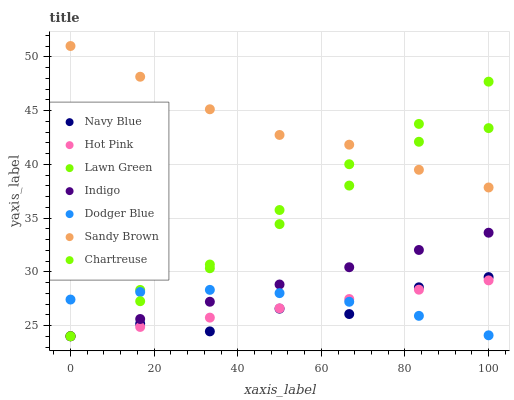Does Navy Blue have the minimum area under the curve?
Answer yes or no. Yes. Does Sandy Brown have the maximum area under the curve?
Answer yes or no. Yes. Does Indigo have the minimum area under the curve?
Answer yes or no. No. Does Indigo have the maximum area under the curve?
Answer yes or no. No. Is Hot Pink the smoothest?
Answer yes or no. Yes. Is Navy Blue the roughest?
Answer yes or no. Yes. Is Indigo the smoothest?
Answer yes or no. No. Is Indigo the roughest?
Answer yes or no. No. Does Lawn Green have the lowest value?
Answer yes or no. Yes. Does Dodger Blue have the lowest value?
Answer yes or no. No. Does Sandy Brown have the highest value?
Answer yes or no. Yes. Does Indigo have the highest value?
Answer yes or no. No. Is Indigo less than Sandy Brown?
Answer yes or no. Yes. Is Sandy Brown greater than Navy Blue?
Answer yes or no. Yes. Does Navy Blue intersect Hot Pink?
Answer yes or no. Yes. Is Navy Blue less than Hot Pink?
Answer yes or no. No. Is Navy Blue greater than Hot Pink?
Answer yes or no. No. Does Indigo intersect Sandy Brown?
Answer yes or no. No. 